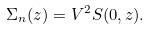<formula> <loc_0><loc_0><loc_500><loc_500>\Sigma _ { n } ( z ) = V ^ { 2 } S ( 0 , z ) .</formula> 